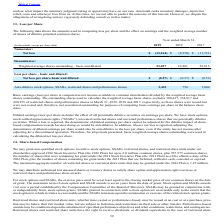According to Agilysys's financial document, What is the Net loss for 2019? According to the financial document, $(13,164) (in thousands). The relevant text states: "Net loss $ (13,164) $ (8,350) $ (11,721)..." Also, What does the table show? the amounts used in computing loss per share and the effect on earnings and the weighted average number of shares of dilutive potential common shares. The document states: "The following data shows the amounts used in computing loss per share and the effect on earnings and the weighted average number of shares of dilutive..." Also, Which shares were used in calculating the diluted net loss per share? basic weighted-average shares outstanding. The document states: "operation. Therefore, for all periods presented, basic weighted-average shares outstanding were used in calculating the diluted net loss per share...." Also, can you calculate: What was the increase / (decrease) in the net loss from 2018 to 2019? Based on the calculation: -13,164 - (- 8,350), the result is -4814 (in thousands). This is based on the information: "Net loss $ (13,164) $ (8,350) $ (11,721) Net loss $ (13,164) $ (8,350) $ (11,721)..." The key data points involved are: 13,164, 8,350. Also, can you calculate: What was the percentage increase / (decrease) in Weighted average shares outstanding - basic and diluted from 2018 to 2019? To answer this question, I need to perform calculations using the financial data. The calculation is: 23,037 / 22,801 - 1, which equals 1.04 (percentage). This is based on the information: "age shares outstanding - basic and diluted 23,037 22,801 22,615 ed average shares outstanding - basic and diluted 23,037 22,801 22,615..." The key data points involved are: 22,801, 23,037. Also, can you calculate: What was the average Anti-dilutive stock options, SSARs, restricted shares and performance shares for 2017-2019? To answer this question, I need to perform calculations using the financial data. The calculation is: (1,433 + 756 + 1,004) / 3, which equals 1064.33 (in thousands). This is based on the information: "s, restricted shares and performance shares 1,433 756 1,004 , SSARs, restricted shares and performance shares 1,433 756 1,004 estricted shares and performance shares 1,433 756 1,004..." The key data points involved are: 1,004, 1,433, 756. 